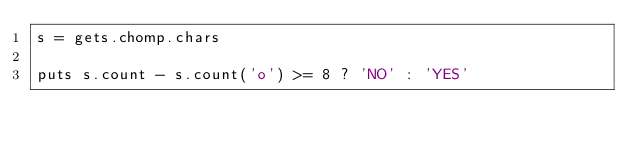<code> <loc_0><loc_0><loc_500><loc_500><_Ruby_>s = gets.chomp.chars

puts s.count - s.count('o') >= 8 ? 'NO' : 'YES'</code> 